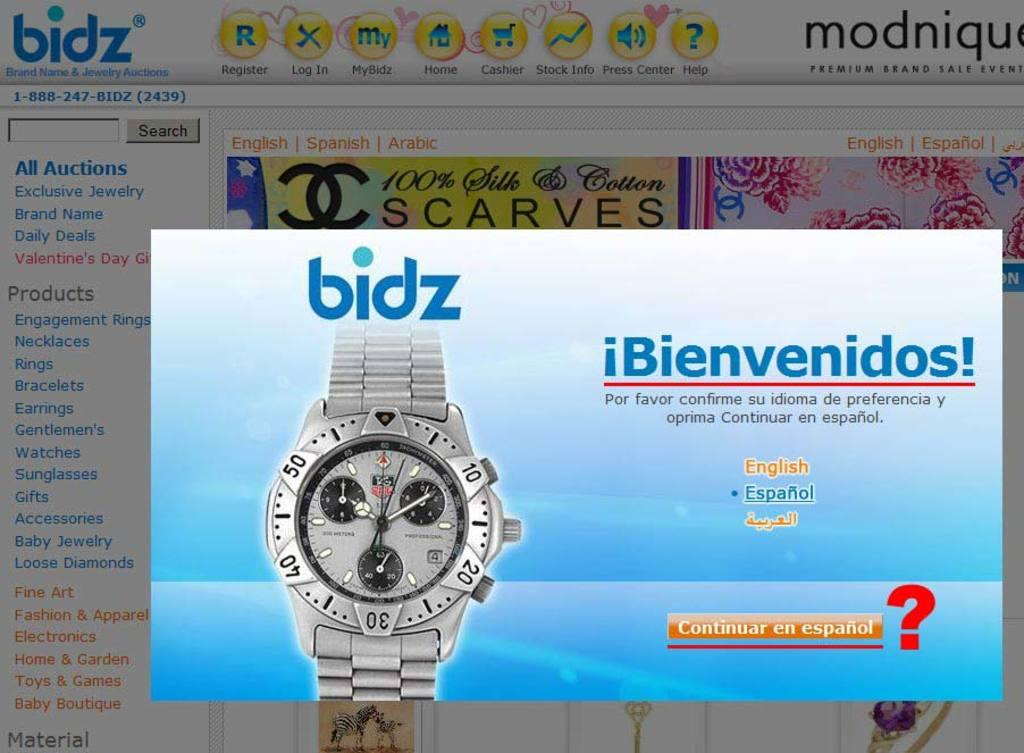Provide a one-sentence caption for the provided image. An auction website and one must choose their language to proceed further. 